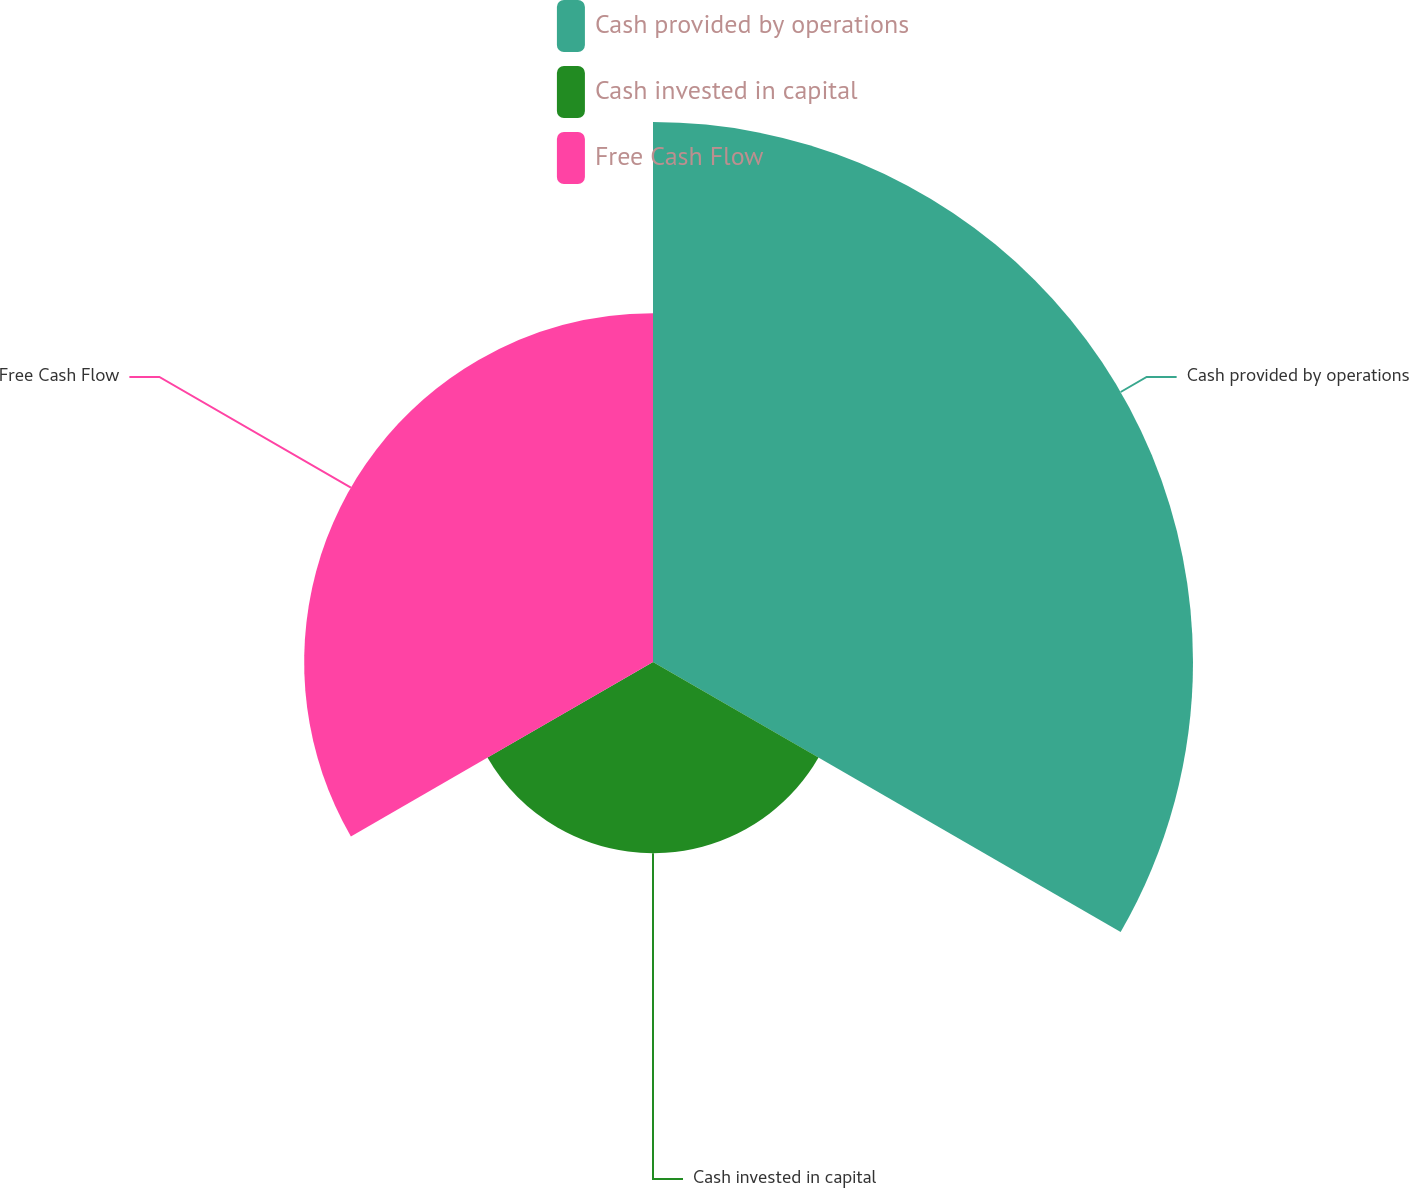Convert chart to OTSL. <chart><loc_0><loc_0><loc_500><loc_500><pie_chart><fcel>Cash provided by operations<fcel>Cash invested in capital<fcel>Free Cash Flow<nl><fcel>50.0%<fcel>17.7%<fcel>32.3%<nl></chart> 